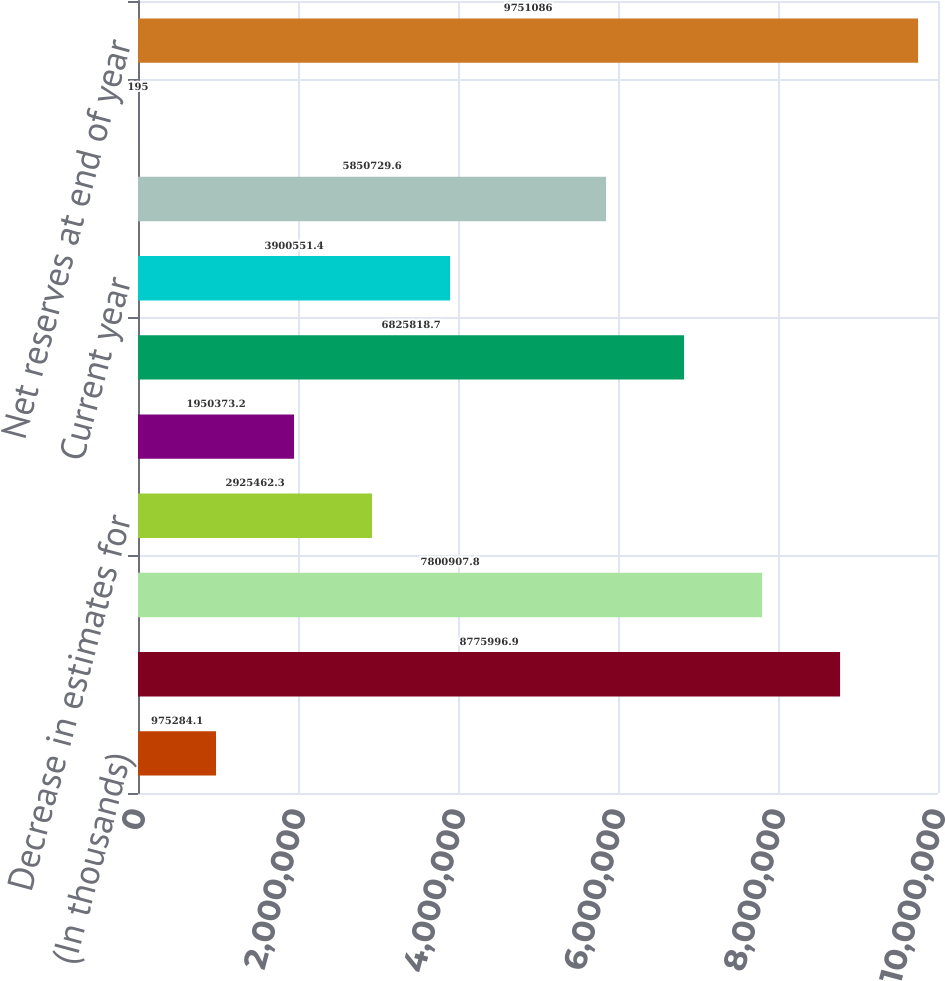Convert chart to OTSL. <chart><loc_0><loc_0><loc_500><loc_500><bar_chart><fcel>(In thousands)<fcel>Net reserves at beginning of<fcel>Claims occurring during the<fcel>Decrease in estimates for<fcel>Loss reserve discount<fcel>Total<fcel>Current year<fcel>Prior years<fcel>Foreign currency translation<fcel>Net reserves at end of year<nl><fcel>975284<fcel>8.776e+06<fcel>7.80091e+06<fcel>2.92546e+06<fcel>1.95037e+06<fcel>6.82582e+06<fcel>3.90055e+06<fcel>5.85073e+06<fcel>195<fcel>9.75109e+06<nl></chart> 